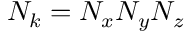<formula> <loc_0><loc_0><loc_500><loc_500>N _ { k } = N _ { x } N _ { y } N _ { z }</formula> 